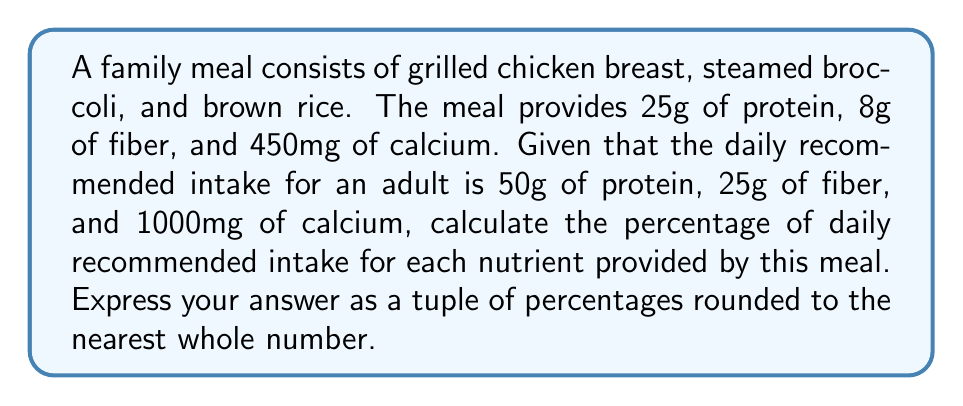Provide a solution to this math problem. To calculate the percentage of daily recommended intake for each nutrient, we need to divide the amount provided by the meal by the daily recommended intake and multiply by 100. Let's do this for each nutrient:

1. Protein:
   $$ \text{Protein Percentage} = \frac{\text{Protein in meal}}{\text{Daily recommended protein}} \times 100 $$
   $$ = \frac{25\text{g}}{50\text{g}} \times 100 = 50\% $$

2. Fiber:
   $$ \text{Fiber Percentage} = \frac{\text{Fiber in meal}}{\text{Daily recommended fiber}} \times 100 $$
   $$ = \frac{8\text{g}}{25\text{g}} \times 100 = 32\% $$

3. Calcium:
   $$ \text{Calcium Percentage} = \frac{\text{Calcium in meal}}{\text{Daily recommended calcium}} \times 100 $$
   $$ = \frac{450\text{mg}}{1000\text{mg}} \times 100 = 45\% $$

Rounding each percentage to the nearest whole number:
- Protein: 50%
- Fiber: 32%
- Calcium: 45%

The answer should be expressed as a tuple of these rounded percentages.
Answer: (50, 32, 45) 